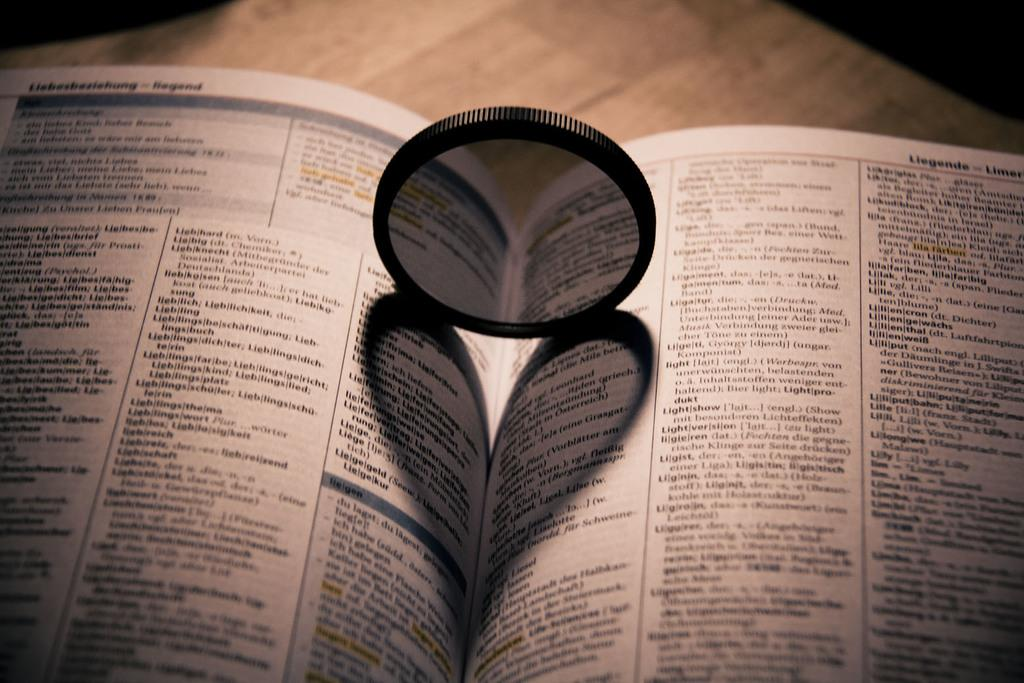What object is at the bottom of the image? There is a book in the image, and it is at the bottom. What is on the book? There is a mirror on the book. What can be seen in the background of the image? There is a table in the background of the image. What type of wrench can be seen in the image? There is no wrench present in the image. 